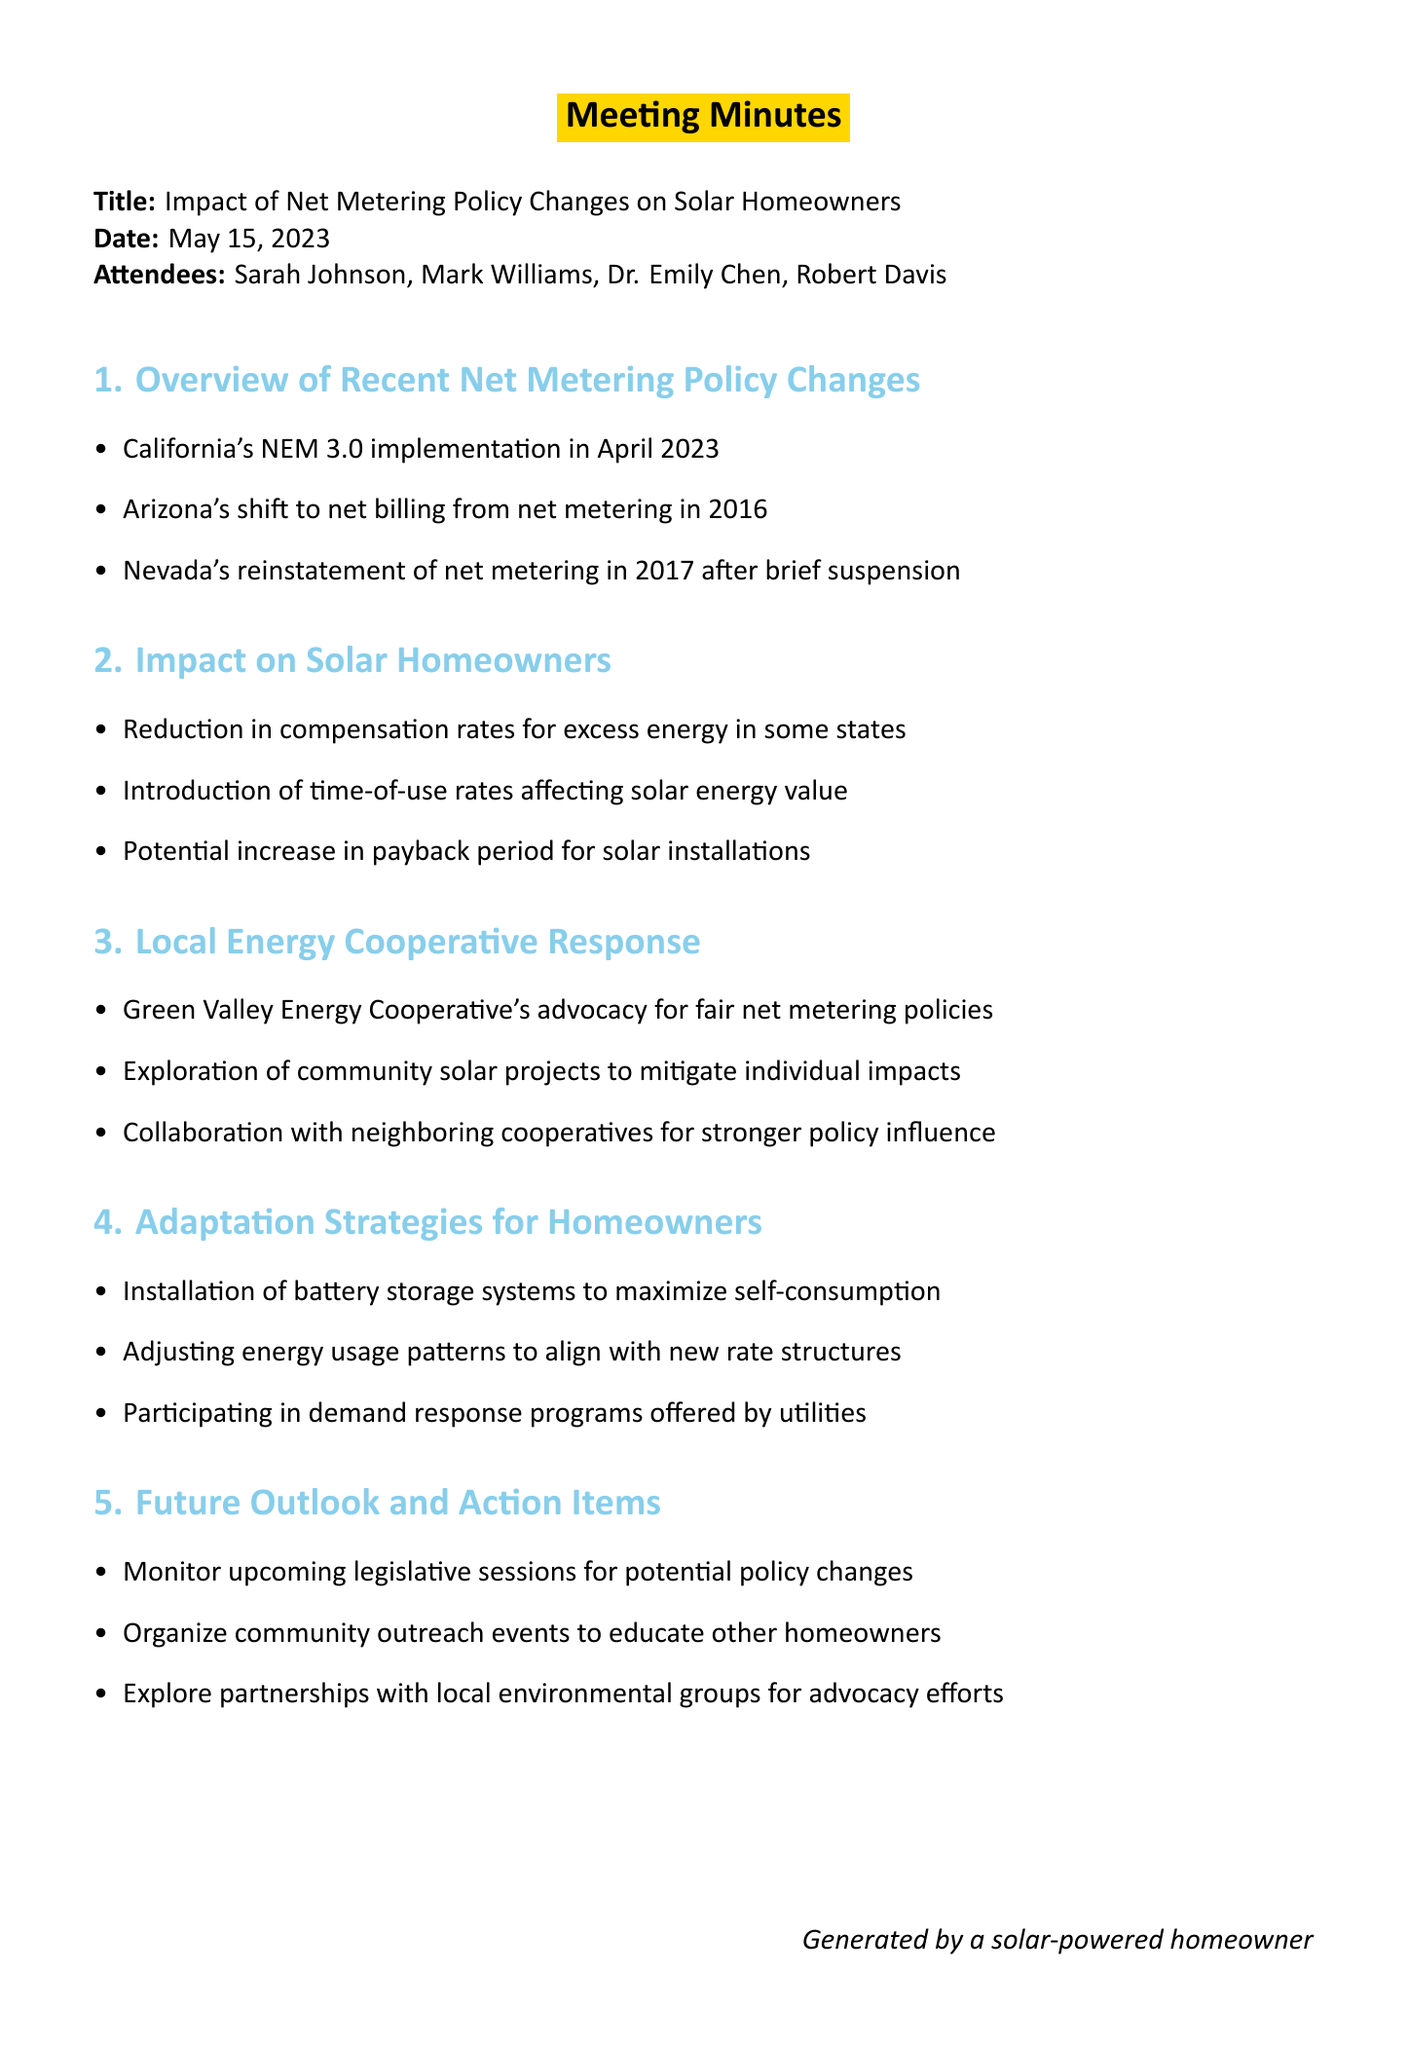What is the title of the meeting? The title of the meeting is stated at the top of the document.
Answer: Impact of Net Metering Policy Changes on Solar Homeowners Who is the local utility company representative? The attendees list includes the names and roles of participants in the meeting.
Answer: Robert Davis What significant policy was implemented in April 2023? This information is found under the section discussing recent net metering policy changes.
Answer: NEM 3.0 What was Arizona's shift in net metering policy? This information is mentioned in the overview of recent net metering policy changes.
Answer: Net billing from net metering in 2016 What impact do the new policies have on compensation rates for excess energy? This detail is described in the section regarding the impact on solar homeowners.
Answer: Reduction What adaptation strategy involves installing storage systems? The adaptation strategies for homeowners section mentions this approach.
Answer: Battery storage systems What is one action item for the future outlook? This is found in the future outlook and action items section of the document.
Answer: Monitor upcoming legislative sessions What type of projects is the Green Valley Energy Cooperative exploring? This is included in the local energy cooperative response section of the document.
Answer: Community solar projects How many attendees were present at the meeting? The document lists all attendees and counts their number.
Answer: Four 